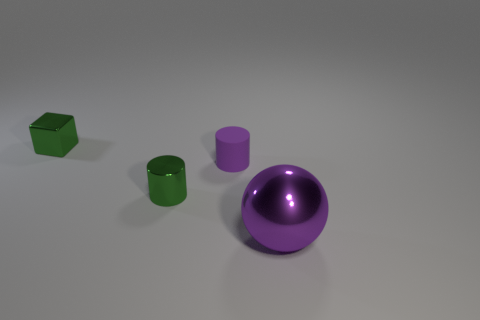Are there any other things that are made of the same material as the tiny purple cylinder?
Your answer should be compact. No. What number of things are on the right side of the green cylinder and left of the big thing?
Keep it short and to the point. 1. There is a tiny cylinder that is left of the purple object that is behind the big purple metallic sphere; what number of small green metallic objects are behind it?
Ensure brevity in your answer.  1. There is a cylinder that is the same color as the big shiny ball; what size is it?
Offer a terse response. Small. The small purple thing is what shape?
Provide a short and direct response. Cylinder. What number of big objects have the same material as the small block?
Provide a succinct answer. 1. There is a cylinder that is made of the same material as the purple sphere; what is its color?
Provide a short and direct response. Green. There is a matte cylinder; does it have the same size as the cylinder that is in front of the small purple matte thing?
Keep it short and to the point. Yes. There is a large purple object that is in front of the tiny green metallic object in front of the purple object that is left of the large shiny thing; what is it made of?
Make the answer very short. Metal. How many objects are either shiny cylinders or cubes?
Offer a terse response. 2. 